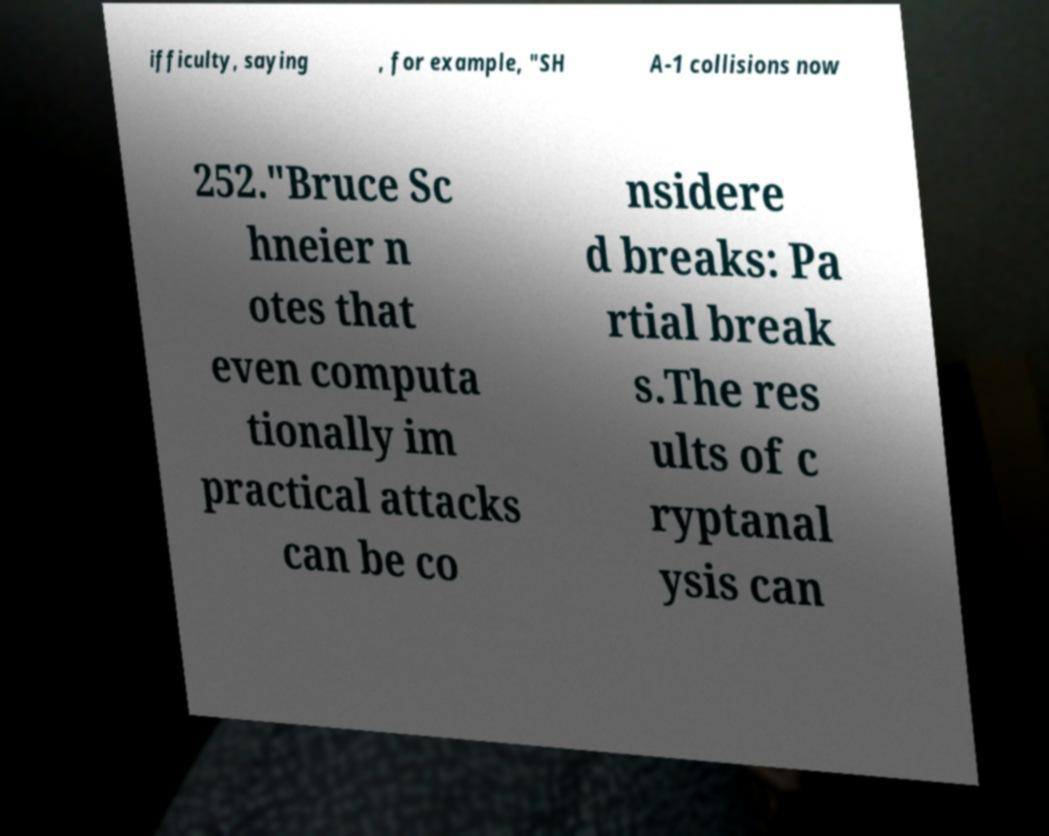Could you extract and type out the text from this image? ifficulty, saying , for example, "SH A-1 collisions now 252."Bruce Sc hneier n otes that even computa tionally im practical attacks can be co nsidere d breaks: Pa rtial break s.The res ults of c ryptanal ysis can 